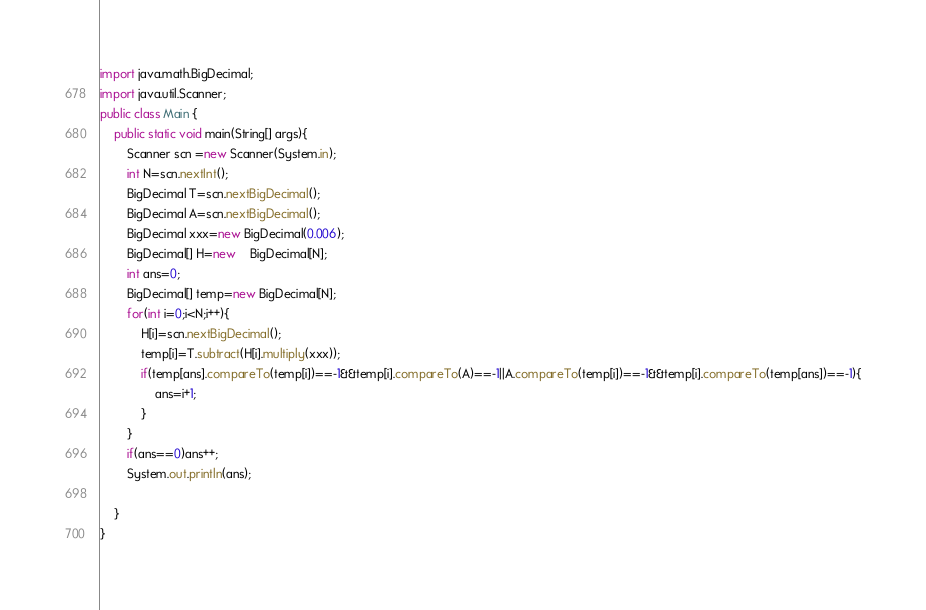<code> <loc_0><loc_0><loc_500><loc_500><_Java_>import java.math.BigDecimal;
import java.util.Scanner;
public class Main {
	public static void main(String[] args){
		Scanner scn =new Scanner(System.in);
		int N=scn.nextInt();
		BigDecimal T=scn.nextBigDecimal();
		BigDecimal A=scn.nextBigDecimal();
		BigDecimal xxx=new BigDecimal(0.006);
		BigDecimal[] H=new 	BigDecimal[N];
		int ans=0;
		BigDecimal[] temp=new BigDecimal[N];
		for(int i=0;i<N;i++){
			H[i]=scn.nextBigDecimal();
			temp[i]=T.subtract(H[i].multiply(xxx));
			if(temp[ans].compareTo(temp[i])==-1&&temp[i].compareTo(A)==-1||A.compareTo(temp[i])==-1&&temp[i].compareTo(temp[ans])==-1){
				ans=i+1;
			}
		}
		if(ans==0)ans++;
		System.out.println(ans);

	}
}
</code> 